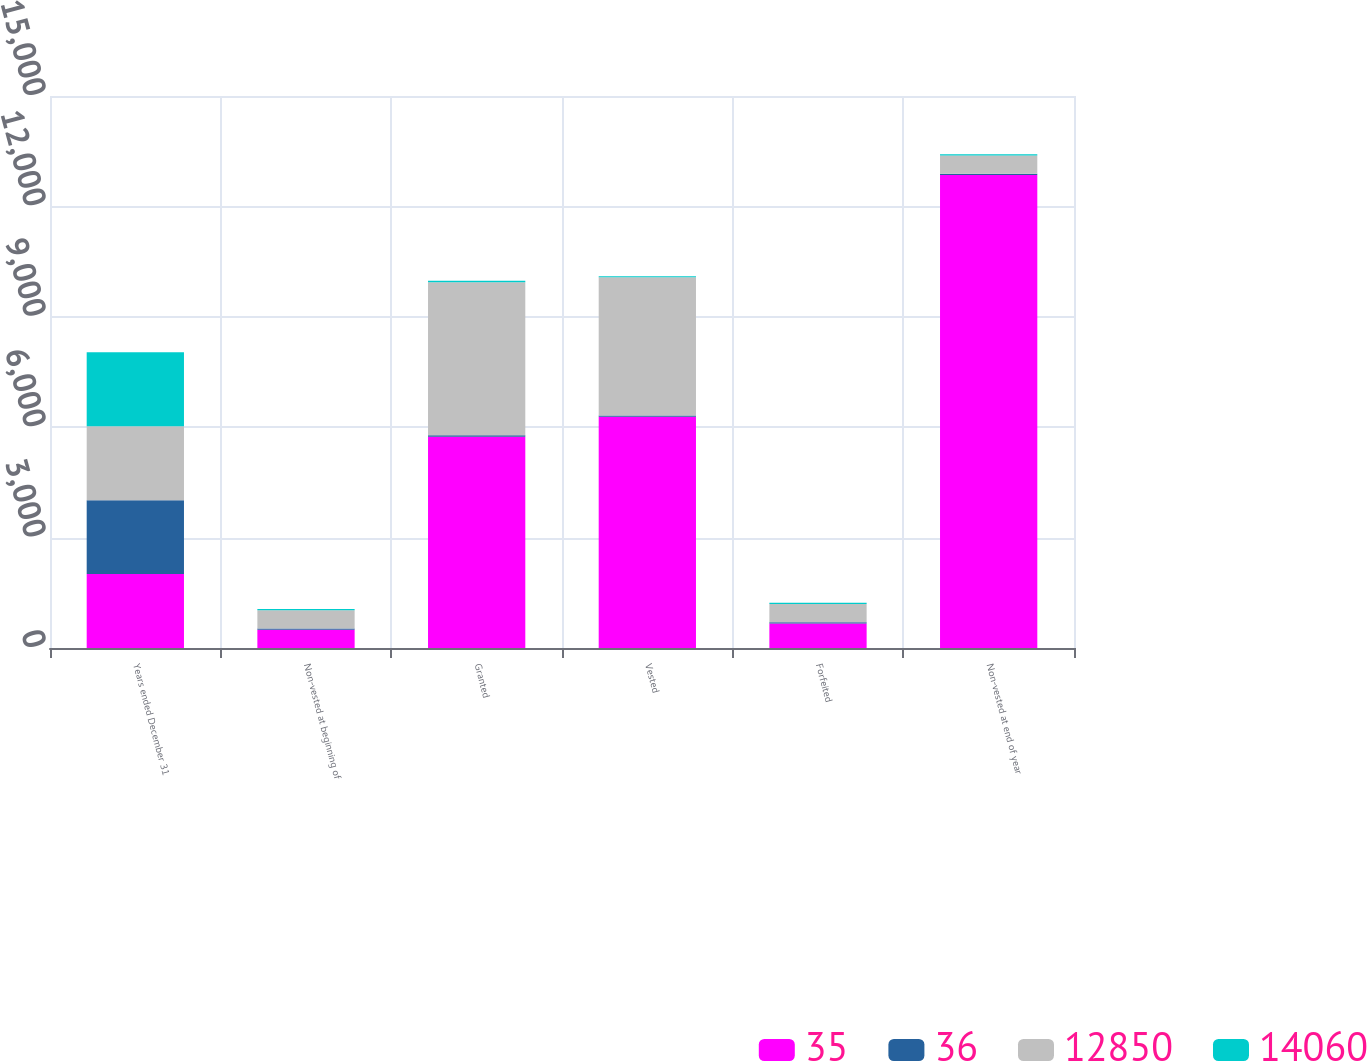Convert chart to OTSL. <chart><loc_0><loc_0><loc_500><loc_500><stacked_bar_chart><ecel><fcel>Years ended December 31<fcel>Non-vested at beginning of<fcel>Granted<fcel>Vested<fcel>Forfeited<fcel>Non-vested at end of year<nl><fcel>35<fcel>2009<fcel>496<fcel>5741<fcel>6285<fcel>666<fcel>12850<nl><fcel>36<fcel>2009<fcel>35<fcel>38<fcel>35<fcel>37<fcel>36<nl><fcel>12850<fcel>2008<fcel>496<fcel>4159<fcel>3753<fcel>496<fcel>496<nl><fcel>14060<fcel>2008<fcel>31<fcel>42<fcel>28<fcel>34<fcel>35<nl></chart> 